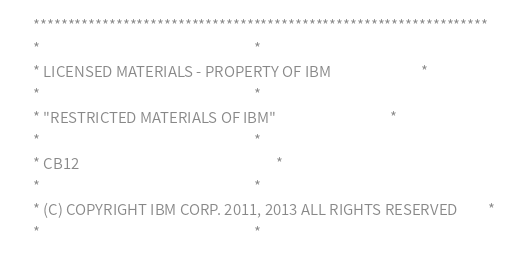Convert code to text. <code><loc_0><loc_0><loc_500><loc_500><_COBOL_>      ******************************************************************
      *                                                                *
      * LICENSED MATERIALS - PROPERTY OF IBM                           *
      *                                                                *
      * "RESTRICTED MATERIALS OF IBM"                                  *
      *                                                                *
      * CB12                                                           *
      *                                                                *
      * (C) COPYRIGHT IBM CORP. 2011, 2013 ALL RIGHTS RESERVED         *
      *                                                                *</code> 